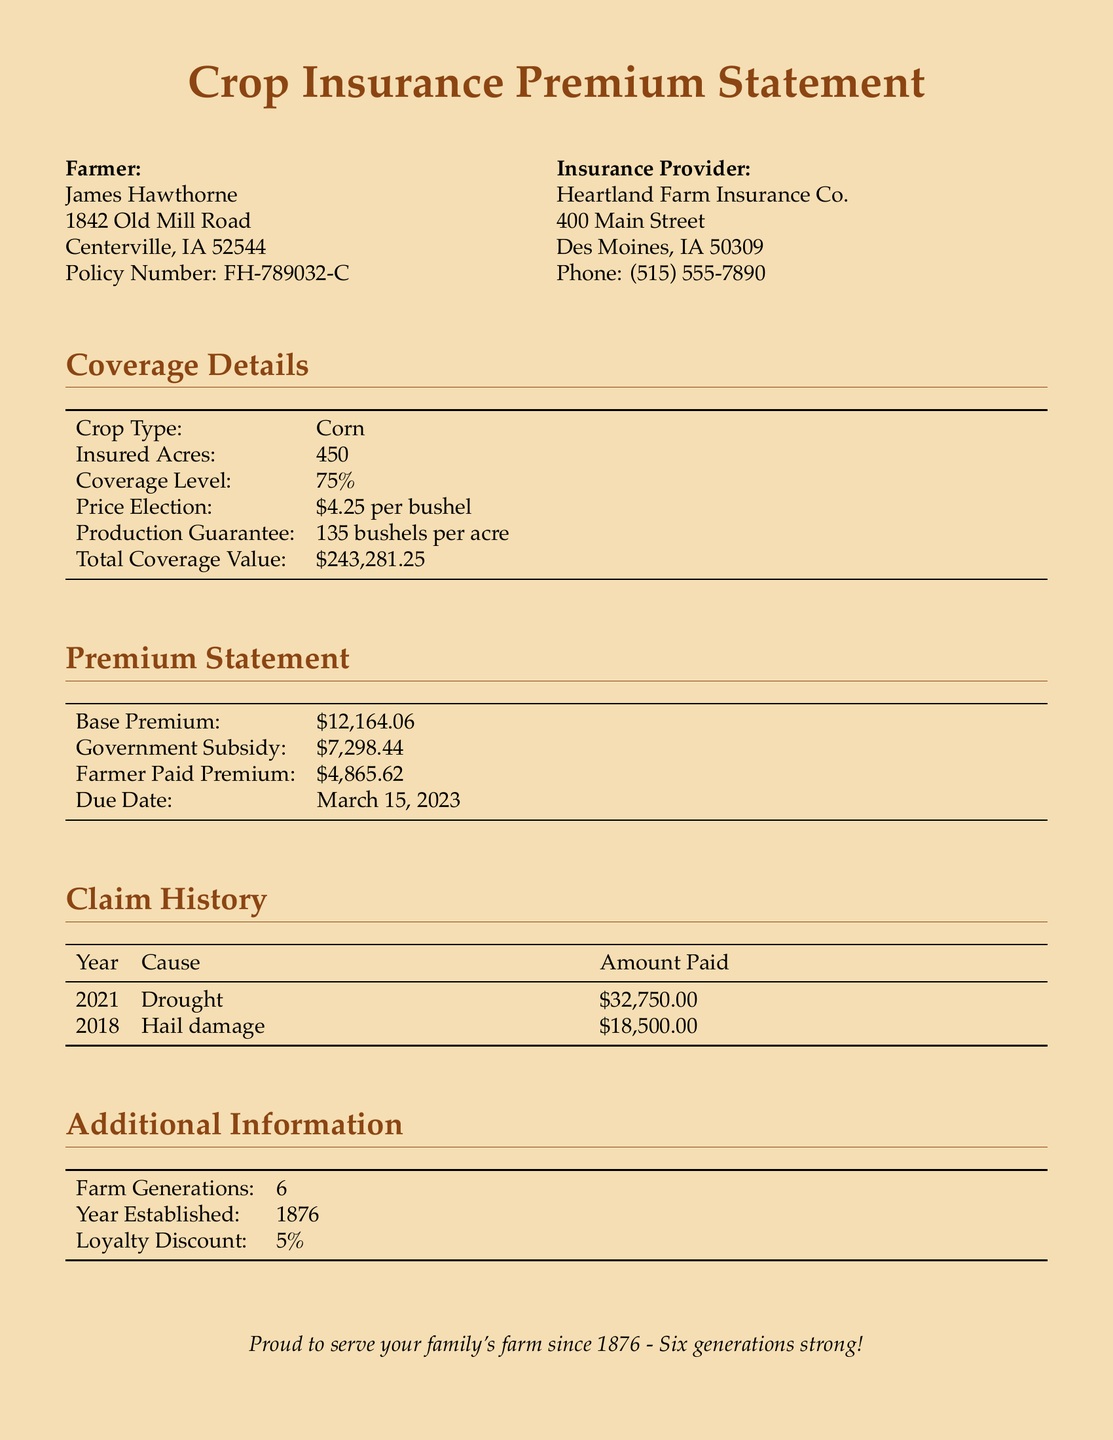What is the policy number? The policy number is listed under the farmer's information in the document.
Answer: FH-789032-C What is the insured acreage? The insured acres can be found in the coverage details table.
Answer: 450 What is the due date for the premium? The due date for the premium is mentioned in the premium statement section.
Answer: March 15, 2023 What percentage of the coverage level is provided? The coverage level percentage is specified in the coverage details table.
Answer: 75% What was the cause of the claim in 2021? The cause of the claim for the specified year can be found in the claim history section.
Answer: Drought How much was paid for the hail damage claim? The amount paid for the hail damage claim is listed in the claim history.
Answer: $18,500.00 What is the total coverage value? The total coverage value is listed in the coverage details section.
Answer: $243,281.25 How long has the farm been established? The year established is stated in the additional information section of the document.
Answer: 1876 What loyalty discount percentage is provided? The loyalty discount percentage is mentioned in the additional information.
Answer: 5% 